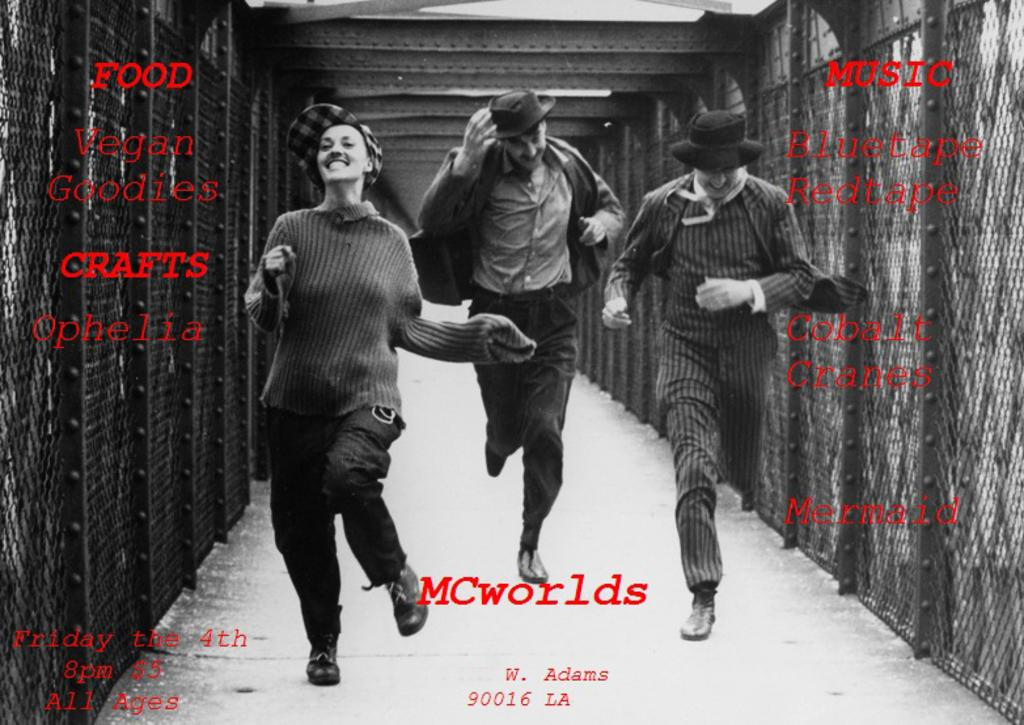What are the people in the image doing? The people in the image are running on a bridge. What can be seen in the background of the image? There are meshes visible in the image. Is there any text present in the image? Yes, there is text present in the image. What type of needle is being used to sew the wing in the image? There is no needle or wing present in the image; it features people running on a bridge with meshes in the background and text. 